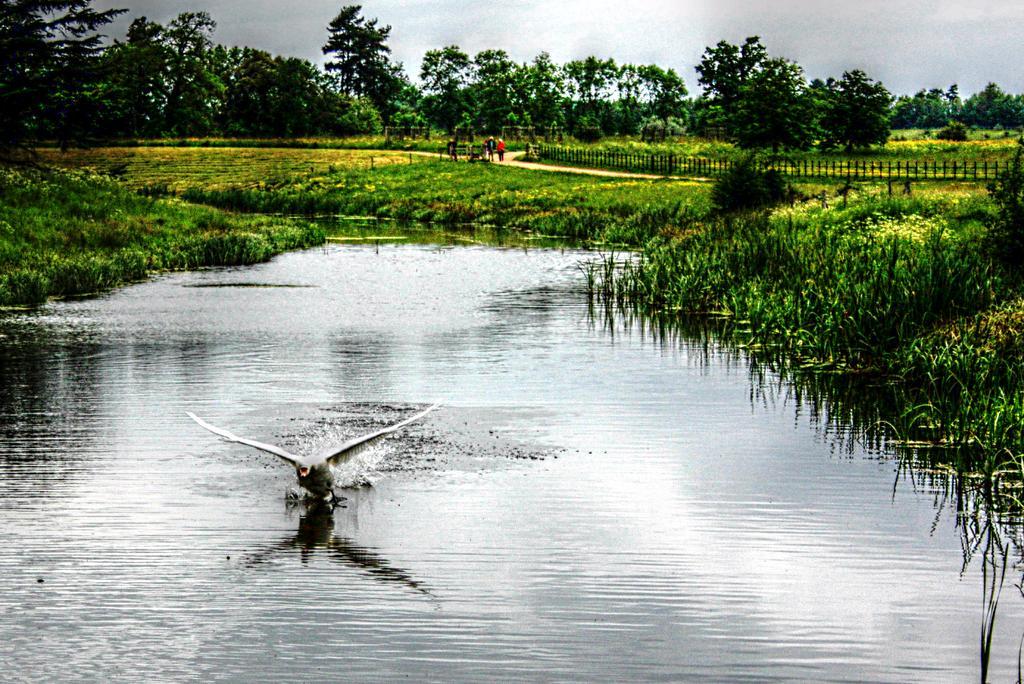Please provide a concise description of this image. In this image there is water and we can see a board. There is grass and we can see a fence. In the background there are trees and sky. There are people. 